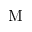Convert formula to latex. <formula><loc_0><loc_0><loc_500><loc_500>M</formula> 